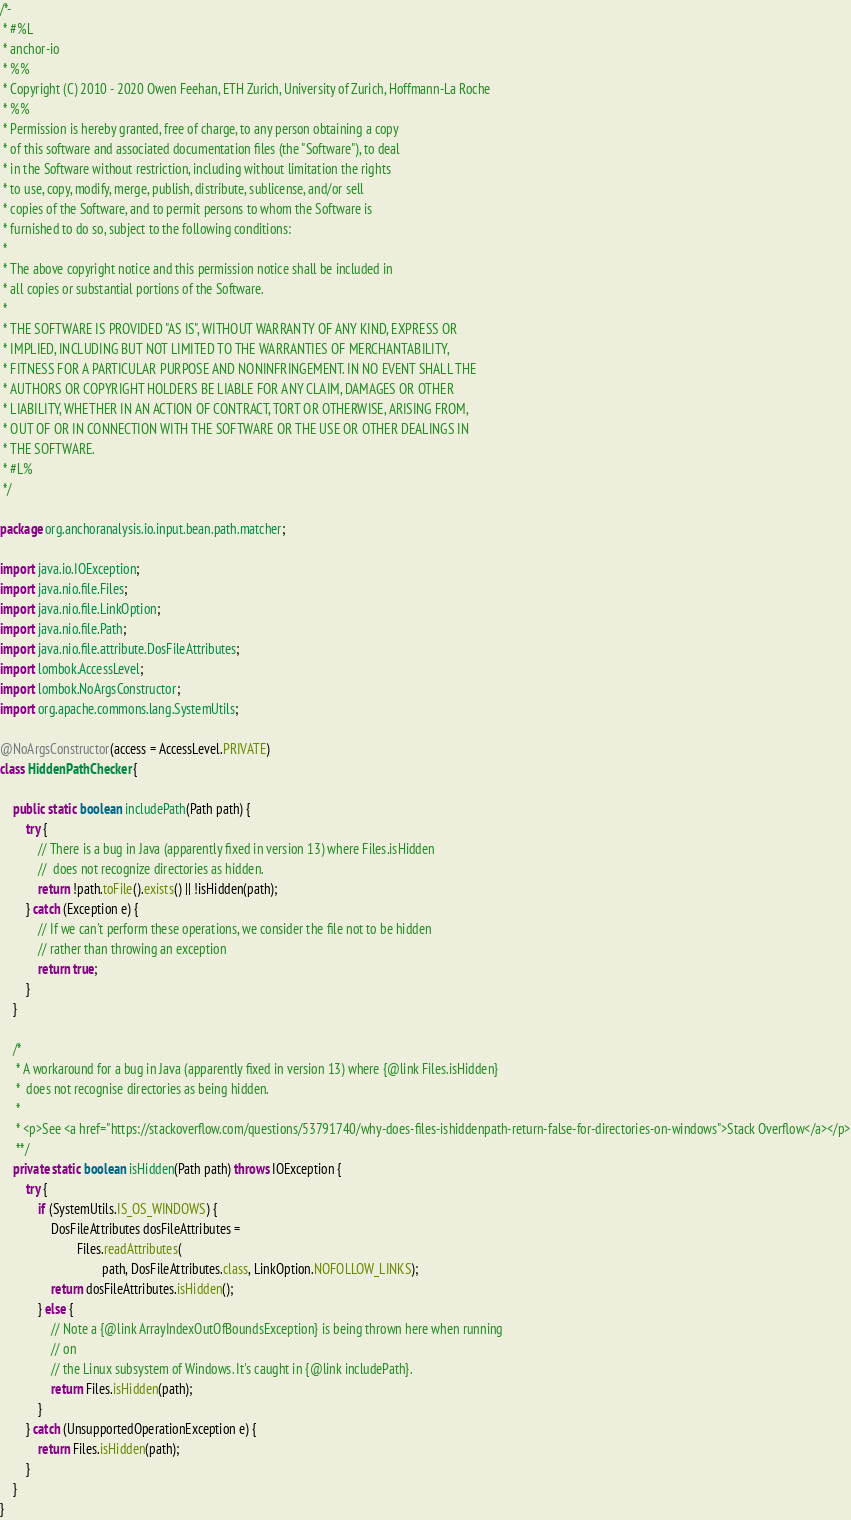Convert code to text. <code><loc_0><loc_0><loc_500><loc_500><_Java_>/*-
 * #%L
 * anchor-io
 * %%
 * Copyright (C) 2010 - 2020 Owen Feehan, ETH Zurich, University of Zurich, Hoffmann-La Roche
 * %%
 * Permission is hereby granted, free of charge, to any person obtaining a copy
 * of this software and associated documentation files (the "Software"), to deal
 * in the Software without restriction, including without limitation the rights
 * to use, copy, modify, merge, publish, distribute, sublicense, and/or sell
 * copies of the Software, and to permit persons to whom the Software is
 * furnished to do so, subject to the following conditions:
 *
 * The above copyright notice and this permission notice shall be included in
 * all copies or substantial portions of the Software.
 *
 * THE SOFTWARE IS PROVIDED "AS IS", WITHOUT WARRANTY OF ANY KIND, EXPRESS OR
 * IMPLIED, INCLUDING BUT NOT LIMITED TO THE WARRANTIES OF MERCHANTABILITY,
 * FITNESS FOR A PARTICULAR PURPOSE AND NONINFRINGEMENT. IN NO EVENT SHALL THE
 * AUTHORS OR COPYRIGHT HOLDERS BE LIABLE FOR ANY CLAIM, DAMAGES OR OTHER
 * LIABILITY, WHETHER IN AN ACTION OF CONTRACT, TORT OR OTHERWISE, ARISING FROM,
 * OUT OF OR IN CONNECTION WITH THE SOFTWARE OR THE USE OR OTHER DEALINGS IN
 * THE SOFTWARE.
 * #L%
 */

package org.anchoranalysis.io.input.bean.path.matcher;

import java.io.IOException;
import java.nio.file.Files;
import java.nio.file.LinkOption;
import java.nio.file.Path;
import java.nio.file.attribute.DosFileAttributes;
import lombok.AccessLevel;
import lombok.NoArgsConstructor;
import org.apache.commons.lang.SystemUtils;

@NoArgsConstructor(access = AccessLevel.PRIVATE)
class HiddenPathChecker {

    public static boolean includePath(Path path) {
        try {
            // There is a bug in Java (apparently fixed in version 13) where Files.isHidden
            //  does not recognize directories as hidden.
            return !path.toFile().exists() || !isHidden(path);
        } catch (Exception e) {
            // If we can't perform these operations, we consider the file not to be hidden
            // rather than throwing an exception
            return true;
        }
    }

    /*
     * A workaround for a bug in Java (apparently fixed in version 13) where {@link Files.isHidden}
     *  does not recognise directories as being hidden.
     *
     * <p>See <a href="https://stackoverflow.com/questions/53791740/why-does-files-ishiddenpath-return-false-for-directories-on-windows">Stack Overflow</a></p>
     **/
    private static boolean isHidden(Path path) throws IOException {
        try {
            if (SystemUtils.IS_OS_WINDOWS) {
                DosFileAttributes dosFileAttributes =
                        Files.readAttributes(
                                path, DosFileAttributes.class, LinkOption.NOFOLLOW_LINKS);
                return dosFileAttributes.isHidden();
            } else {
                // Note a {@link ArrayIndexOutOfBoundsException} is being thrown here when running
                // on
                // the Linux subsystem of Windows. It's caught in {@link includePath}.
                return Files.isHidden(path);
            }
        } catch (UnsupportedOperationException e) {
            return Files.isHidden(path);
        }
    }
}
</code> 